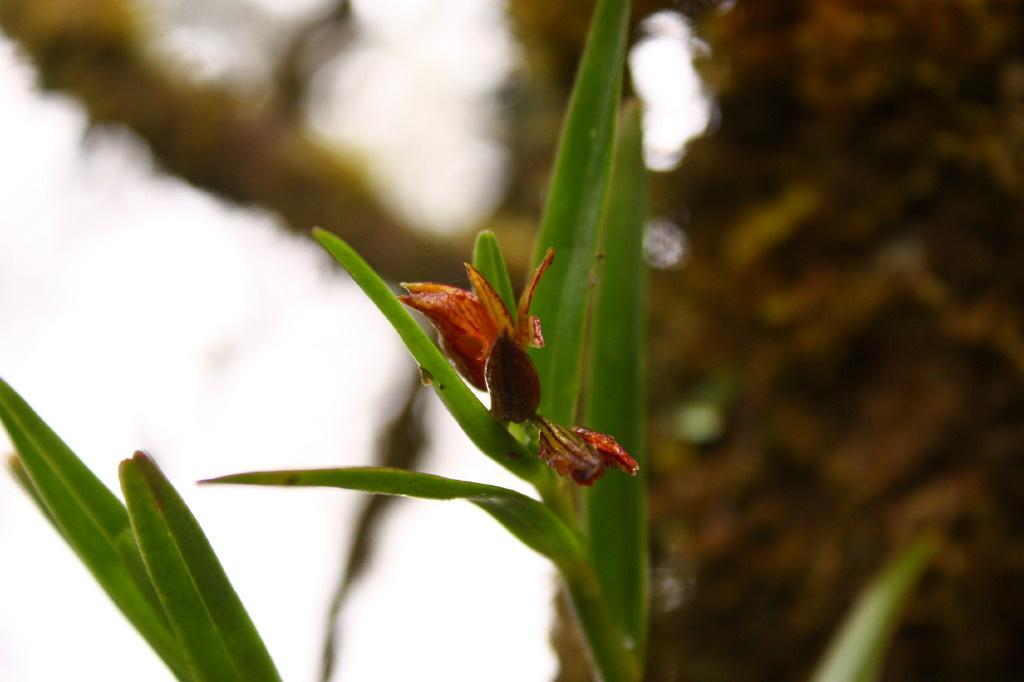What is the main subject of the image? There is a plant in the image. Can you describe the background of the image? The background of the image is blurred. What type of note is being played by the plant in the image? There is no note being played by the plant in the image, as plants do not have the ability to play music. 